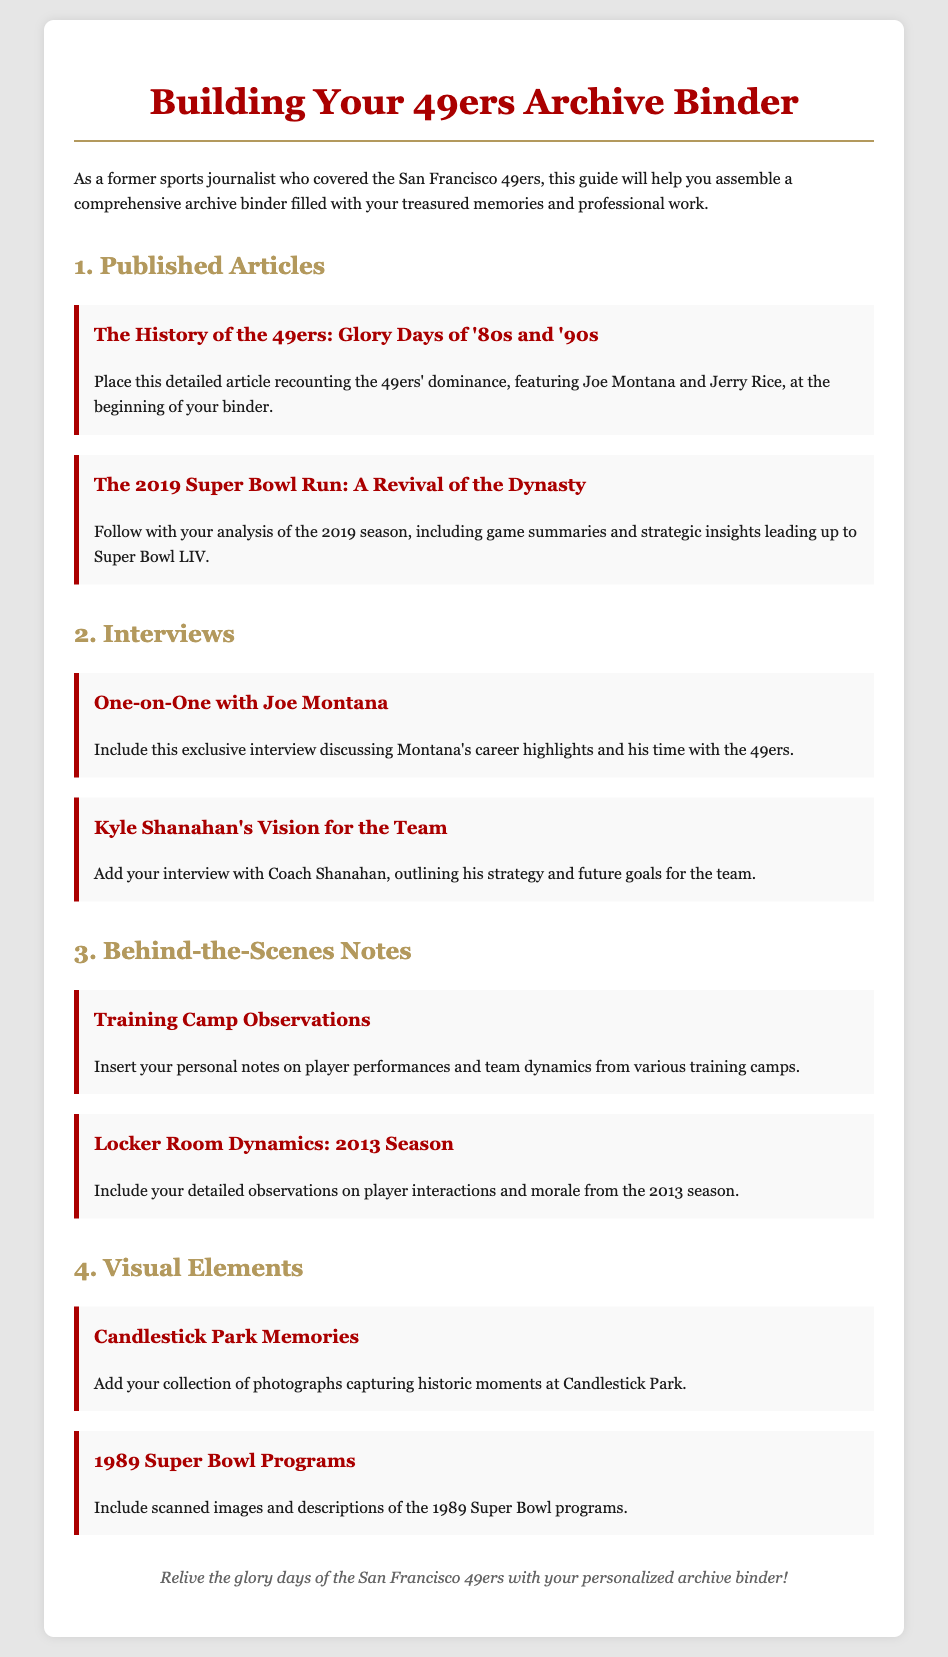What is the title of the first article? The first article listed is "The History of the 49ers: Glory Days of '80s and '90s".
Answer: The History of the 49ers: Glory Days of '80s and '90s Who is featured in the exclusive interview? The exclusive interview is with Joe Montana, discussing his career highlights and time with the 49ers.
Answer: Joe Montana What season do the locker room dynamics notes pertain to? The notes on locker room dynamics specifically mention the 2013 season.
Answer: 2013 What significant event does the second article analyze? The second article analyzes the San Francisco 49ers' successful 2019 season leading up to Super Bowl LIV.
Answer: 2019 Super Bowl How many published articles are listed in the document? There are two published articles mentioned in the assembly instructions.
Answer: 2 What type of personal notes are included in the third section? The third section includes personal notes on player performances and team dynamics from training camps.
Answer: Training Camp Observations What is one type of visual element suggested to include? One suggested visual element is photographs capturing historic moments at Candlestick Park.
Answer: Candlestick Park Memories Who is the head coach interviewed in the document? The head coach interviewed is Kyle Shanahan, discussing his strategy for the team.
Answer: Kyle Shanahan 